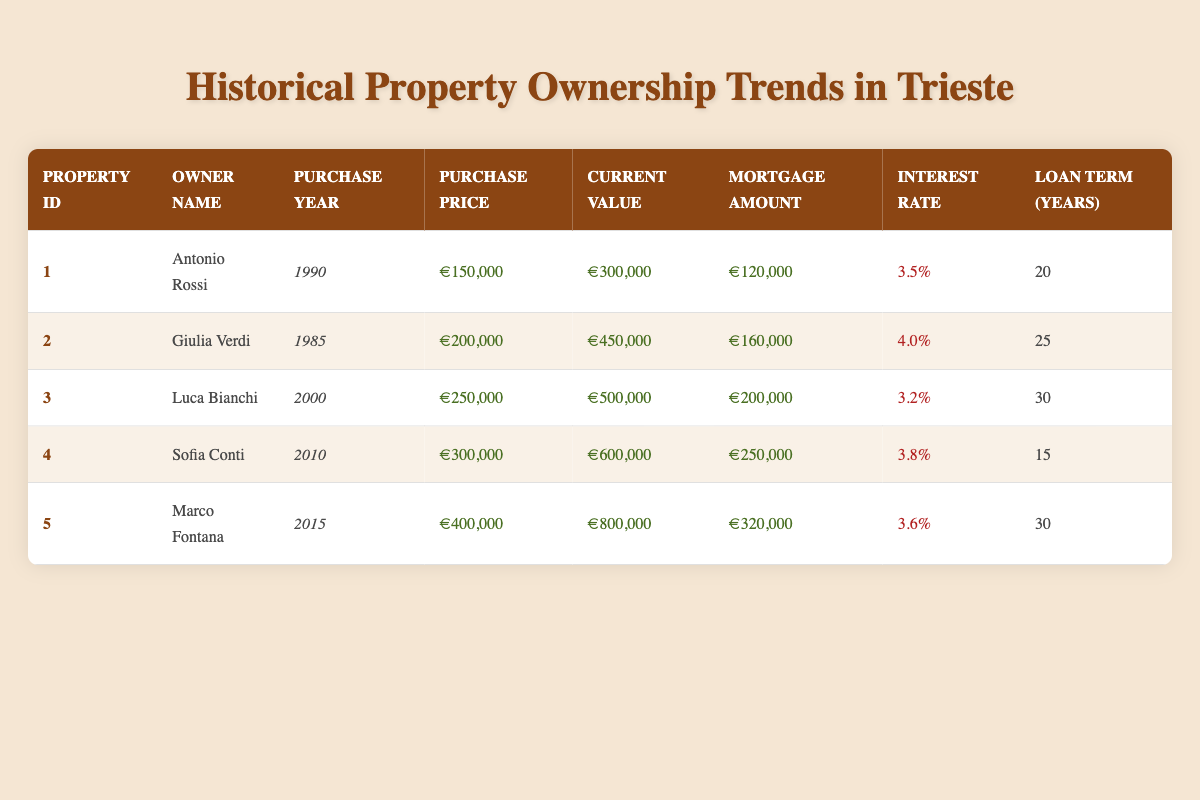What is the purchase price of the property owned by Giulia Verdi? From the table, we locate the row corresponding to Giulia Verdi. The purchase price is listed in the "Purchase Price" column, which shows €200,000.
Answer: €200,000 Which property has the highest current value? Looking at the "Current Value" column, we note the values: €300,000 for Antonio Rossi, €450,000 for Giulia Verdi, €500,000 for Luca Bianchi, €600,000 for Sofia Conti, and €800,000 for Marco Fontana. The highest value is €800,000 for Marco Fontana.
Answer: €800,000 How many properties have an interest rate below 4%? Reviewing the "Interest Rate" column, we find the following rates: 3.5%, 4.0%, 3.2%, 3.8%, and 3.6%. The rates below 4% are 3.5% (Antonio Rossi), 3.2% (Luca Bianchi), and 3.6% (Marco Fontana), totaling three properties.
Answer: 3 What is the total mortgage amount for all properties listed? We sum the mortgage amounts from the "Mortgage Amount" column: €120,000 + €160,000 + €200,000 + €250,000 + €320,000 = €1,050,000, which is the total mortgage amount for all properties.
Answer: €1,050,000 Is the current value of the property owned by Antonio Rossi higher than the purchase price? Comparing the values, Antonio Rossi's purchase price is €150,000 and the current value is €300,000. Since €300,000 is greater than €150,000, the statement is true.
Answer: Yes What is the average purchase price of all the properties? We take the purchase prices: €150,000, €200,000, €250,000, €300,000, and €400,000. Their total is €150,000 + €200,000 + €250,000 + €300,000 + €400,000 = €1,300,000. Dividing by 5 (the number of properties) gives us an average of €1,300,000 / 5 = €260,000.
Answer: €260,000 Who has the longest loan term and what is it? From the "Loan Term (Years)" column, we see the values: 20, 25, 30, 15, and 30. Both Luca Bianchi and Marco Fontana have a loan term of 30 years, which is the longest.
Answer: Luca Bianchi and Marco Fontana, 30 years What percentage increase has occurred in the current value of Marco Fontana's property compared to the purchase price? Calculating the increase: Current value €800,000 minus purchase price €400,000 equals €400,000. To find the percentage increase, we divide the increase by the purchase price: (€400,000 / €400,000) * 100% = 100%.
Answer: 100% 